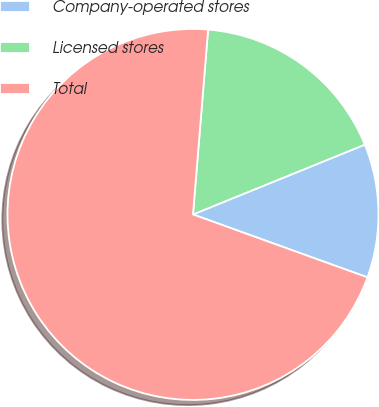Convert chart. <chart><loc_0><loc_0><loc_500><loc_500><pie_chart><fcel>Company-operated stores<fcel>Licensed stores<fcel>Total<nl><fcel>11.65%<fcel>17.56%<fcel>70.79%<nl></chart> 